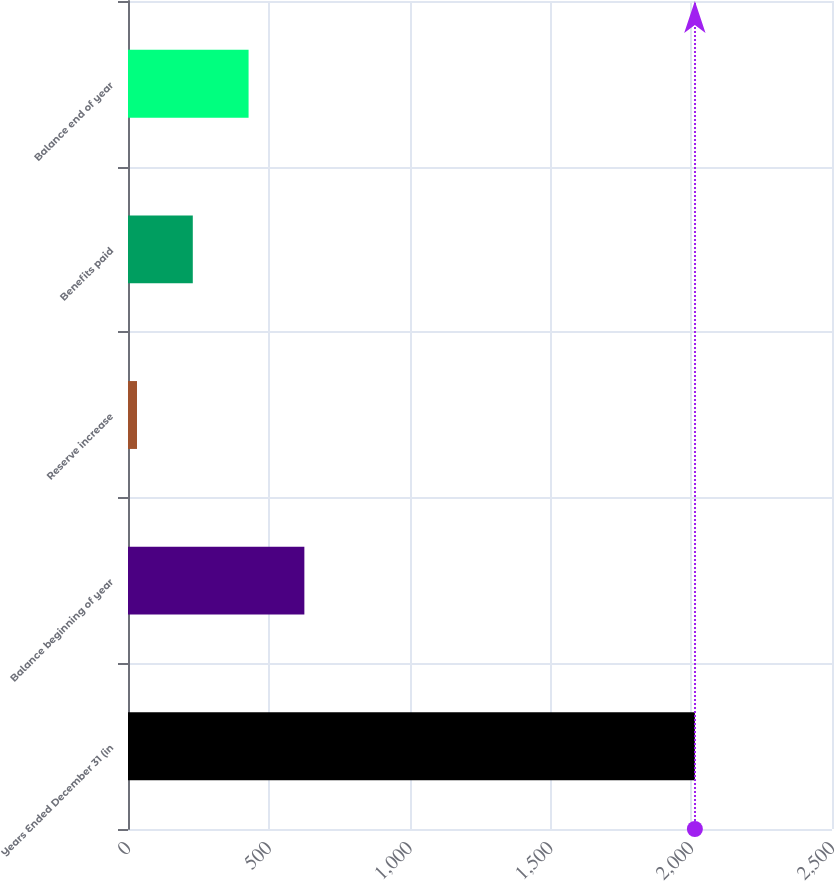Convert chart. <chart><loc_0><loc_0><loc_500><loc_500><bar_chart><fcel>Years Ended December 31 (in<fcel>Balance beginning of year<fcel>Reserve increase<fcel>Benefits paid<fcel>Balance end of year<nl><fcel>2013<fcel>626.3<fcel>32<fcel>230.1<fcel>428.2<nl></chart> 